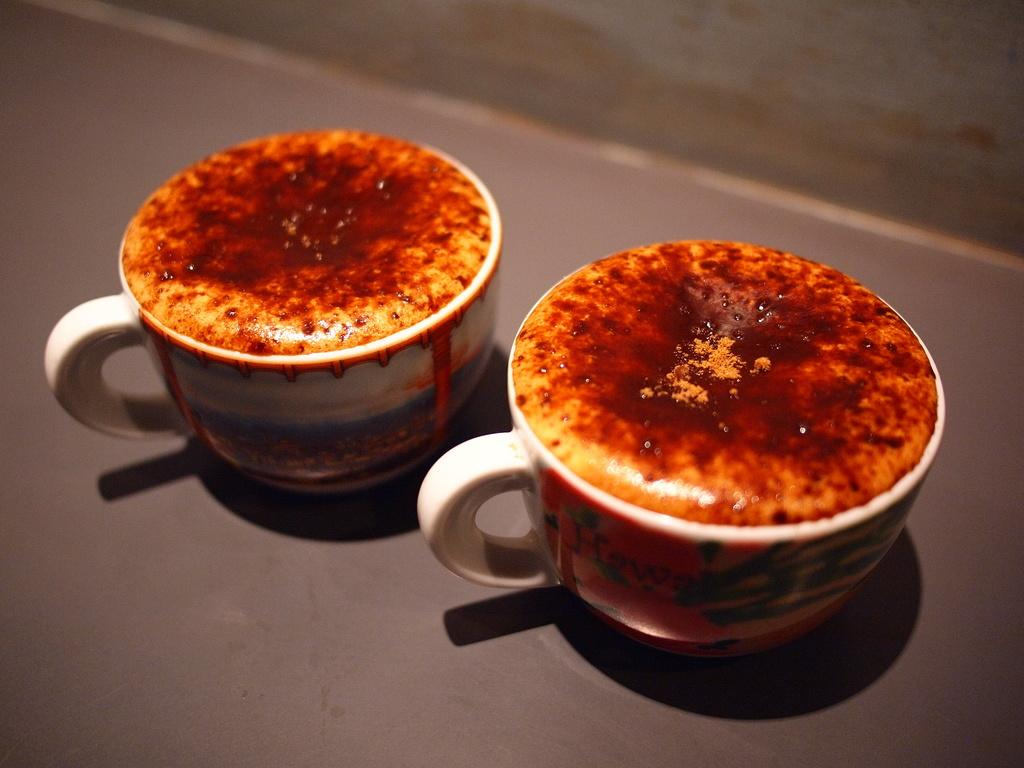What objects are present in the image? There are two coffee cups in the image. Where are the coffee cups located? The coffee cups are kept on the floor. How are the coffee cups positioned in the image? The coffee cups are in the middle of the image. Reasoning: Let'g: Let's think step by step in order to produce the conversation. We start by identifying the main objects in the image, which are the coffee cups. Then, we describe their location, which is on the floor. Finally, we mention their position within the image, which is in the middle. Each question is designed to elicit a specific detail about the image that is known from the provided facts. Absurd Question/Answer: What type of protest is taking place in the image? There is no protest present in the image; it only features two coffee cups on the floor. 